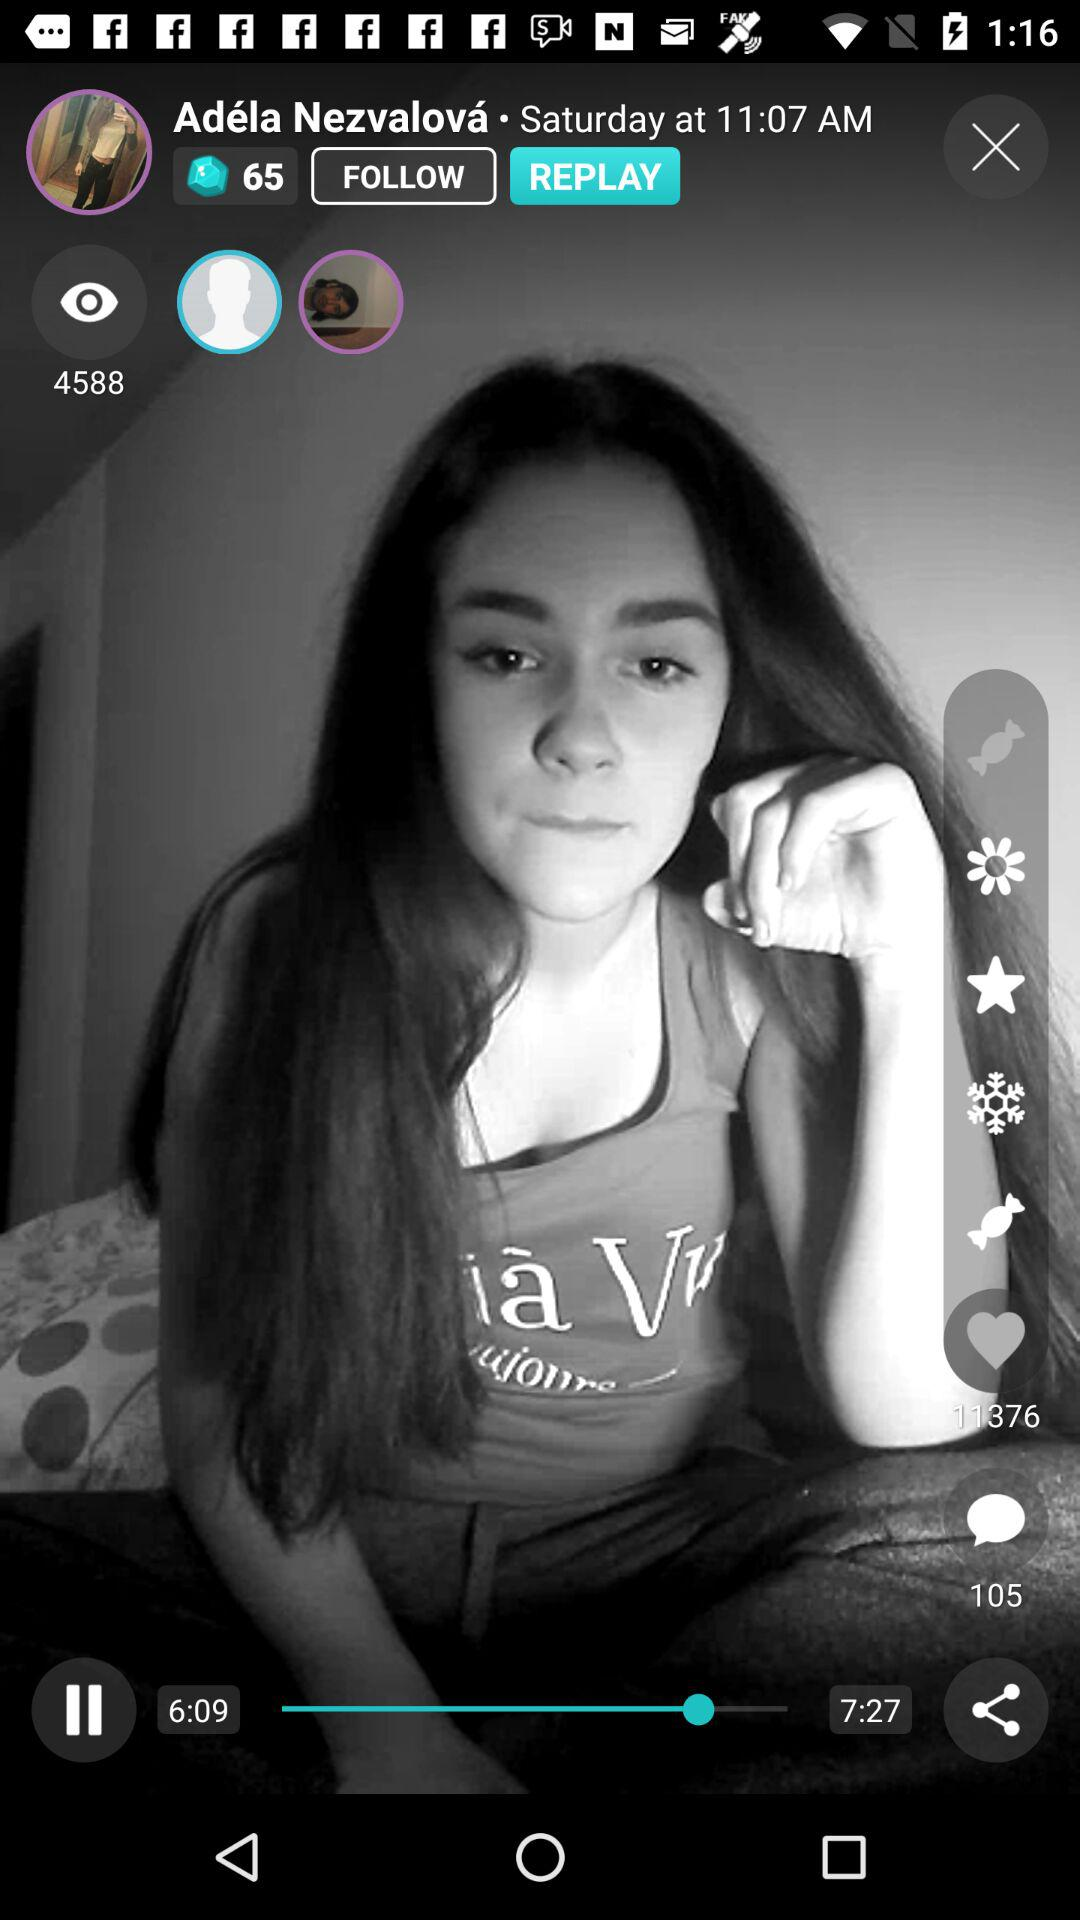What is the time? The time is 11:07 AM. 